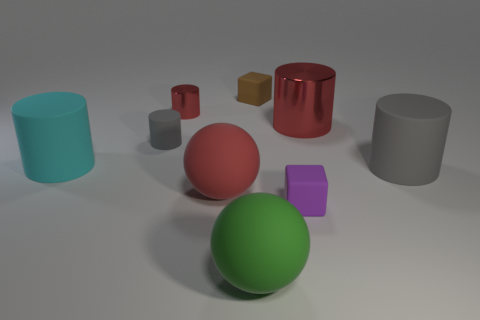There is a red rubber object; is it the same shape as the small object that is in front of the large red rubber thing?
Ensure brevity in your answer.  No. There is a metallic object right of the large green matte ball; what is its shape?
Your answer should be compact. Cylinder. Is the shape of the large gray object the same as the brown rubber thing?
Provide a short and direct response. No. There is a brown thing that is the same shape as the purple rubber object; what is its size?
Make the answer very short. Small. There is a metal thing on the right side of the purple thing; is its size the same as the purple rubber block?
Keep it short and to the point. No. What size is the cylinder that is both in front of the tiny gray cylinder and on the right side of the brown block?
Your answer should be compact. Large. There is a big cylinder that is the same color as the small rubber cylinder; what material is it?
Give a very brief answer. Rubber. What number of other cylinders are the same color as the small metal cylinder?
Ensure brevity in your answer.  1. Is the number of big green balls that are in front of the large green matte object the same as the number of tiny red matte cylinders?
Your answer should be very brief. Yes. What is the color of the small matte cylinder?
Offer a terse response. Gray. 